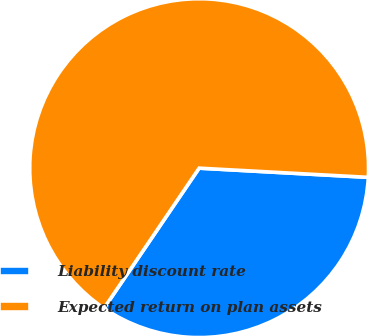Convert chart to OTSL. <chart><loc_0><loc_0><loc_500><loc_500><pie_chart><fcel>Liability discount rate<fcel>Expected return on plan assets<nl><fcel>33.63%<fcel>66.37%<nl></chart> 